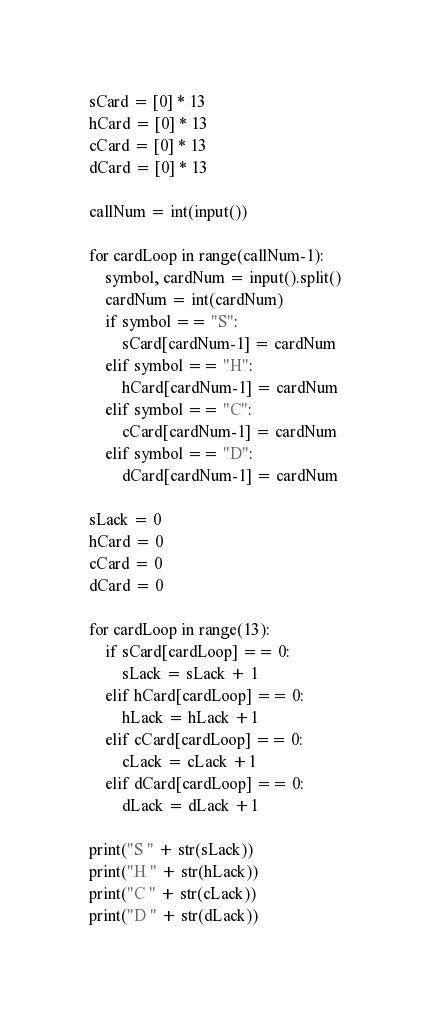<code> <loc_0><loc_0><loc_500><loc_500><_Python_>sCard = [0] * 13
hCard = [0] * 13 
cCard = [0] * 13
dCard = [0] * 13

callNum = int(input())

for cardLoop in range(callNum-1):
    symbol, cardNum = input().split()
    cardNum = int(cardNum)
    if symbol == "S":
        sCard[cardNum-1] = cardNum
    elif symbol == "H":
        hCard[cardNum-1] = cardNum
    elif symbol == "C":
        cCard[cardNum-1] = cardNum
    elif symbol == "D":
        dCard[cardNum-1] = cardNum

sLack = 0
hCard = 0
cCard = 0
dCard = 0

for cardLoop in range(13):
    if sCard[cardLoop] == 0:
        sLack = sLack + 1
    elif hCard[cardLoop] == 0:
        hLack = hLack +1
    elif cCard[cardLoop] == 0:
        cLack = cLack +1    
    elif dCard[cardLoop] == 0:
        dLack = dLack +1

print("S " + str(sLack))
print("H " + str(hLack))
print("C " + str(cLack))
print("D " + str(dLack))
</code> 